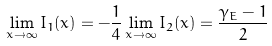Convert formula to latex. <formula><loc_0><loc_0><loc_500><loc_500>\lim _ { x \rightarrow \infty } I _ { 1 } ( x ) = - \frac { 1 } { 4 } \lim _ { x \rightarrow \infty } I _ { 2 } ( x ) = \frac { \gamma _ { E } - 1 } { 2 }</formula> 